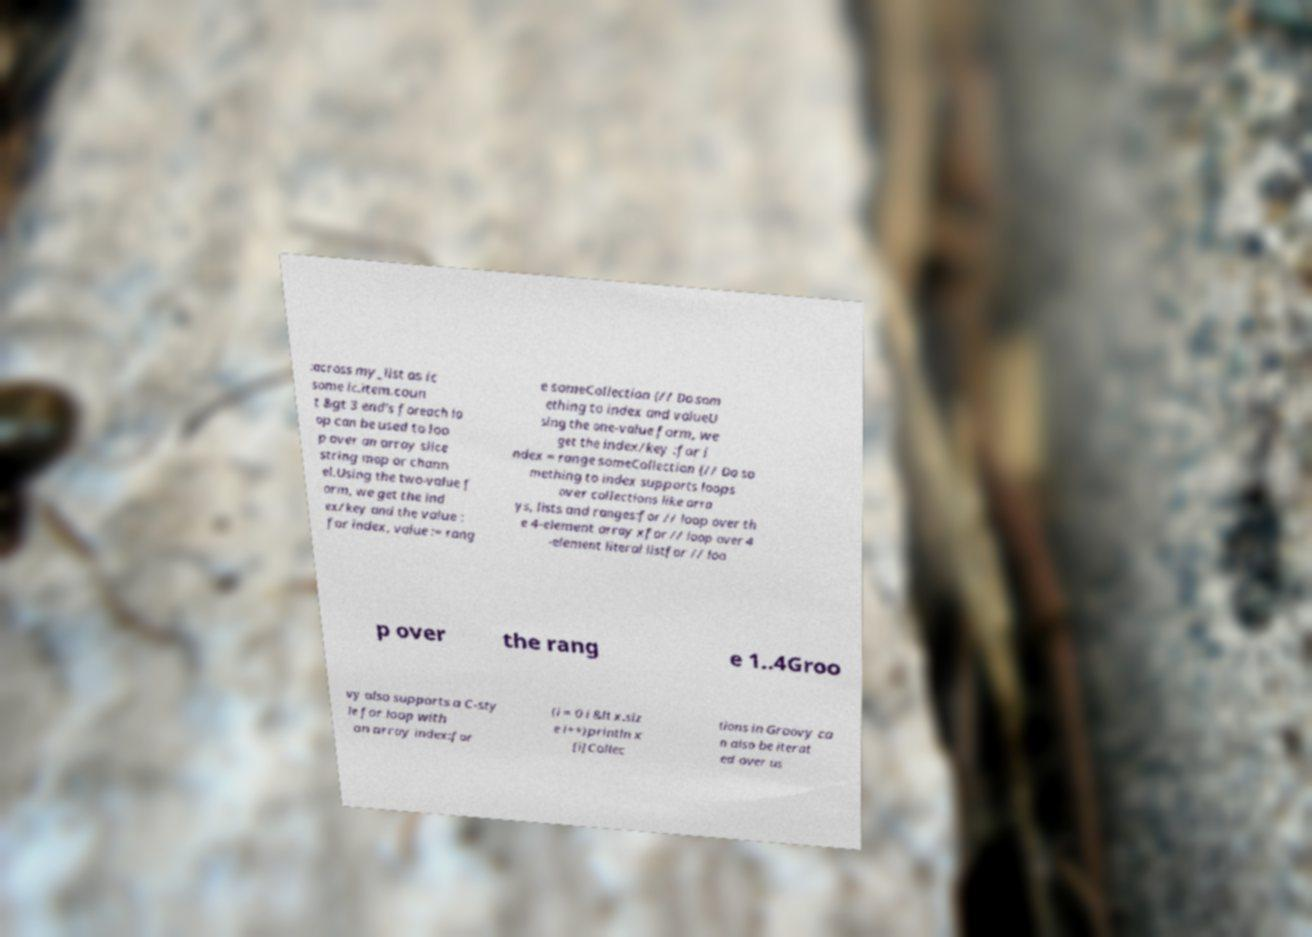For documentation purposes, I need the text within this image transcribed. Could you provide that? :across my_list as ic some ic.item.coun t &gt 3 end's foreach lo op can be used to loo p over an array slice string map or chann el.Using the two-value f orm, we get the ind ex/key and the value : for index, value := rang e someCollection {// Do som ething to index and valueU sing the one-value form, we get the index/key :for i ndex = range someCollection {// Do so mething to index supports loops over collections like arra ys, lists and ranges:for // loop over th e 4-element array xfor // loop over 4 -element literal listfor // loo p over the rang e 1..4Groo vy also supports a C-sty le for loop with an array index:for (i = 0 i &lt x.siz e i++)println x [i]Collec tions in Groovy ca n also be iterat ed over us 